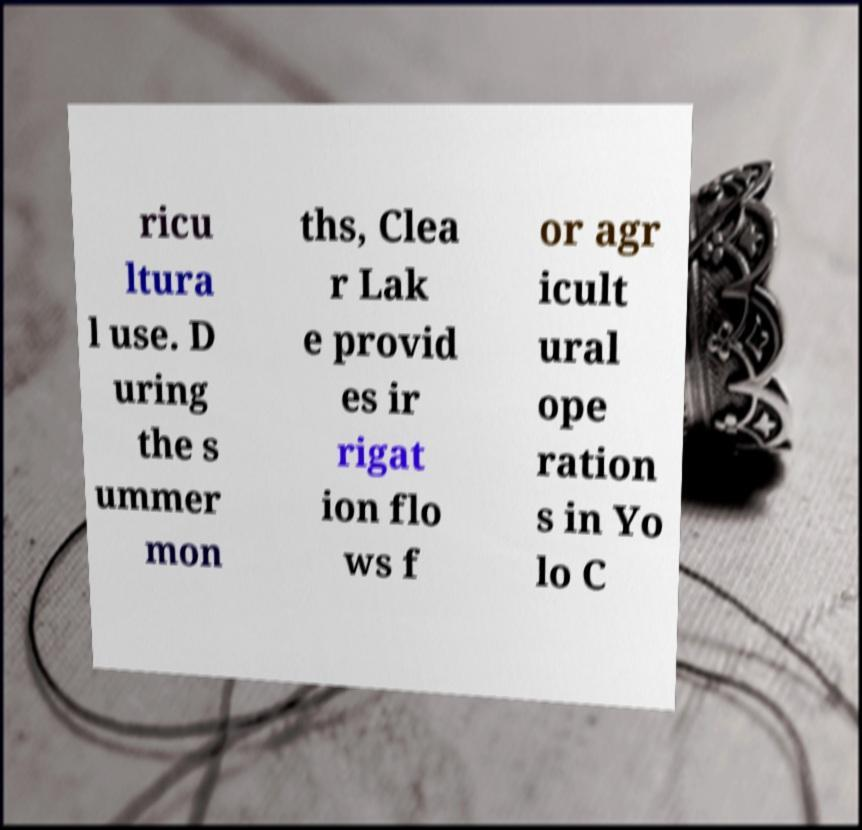Can you read and provide the text displayed in the image?This photo seems to have some interesting text. Can you extract and type it out for me? ricu ltura l use. D uring the s ummer mon ths, Clea r Lak e provid es ir rigat ion flo ws f or agr icult ural ope ration s in Yo lo C 